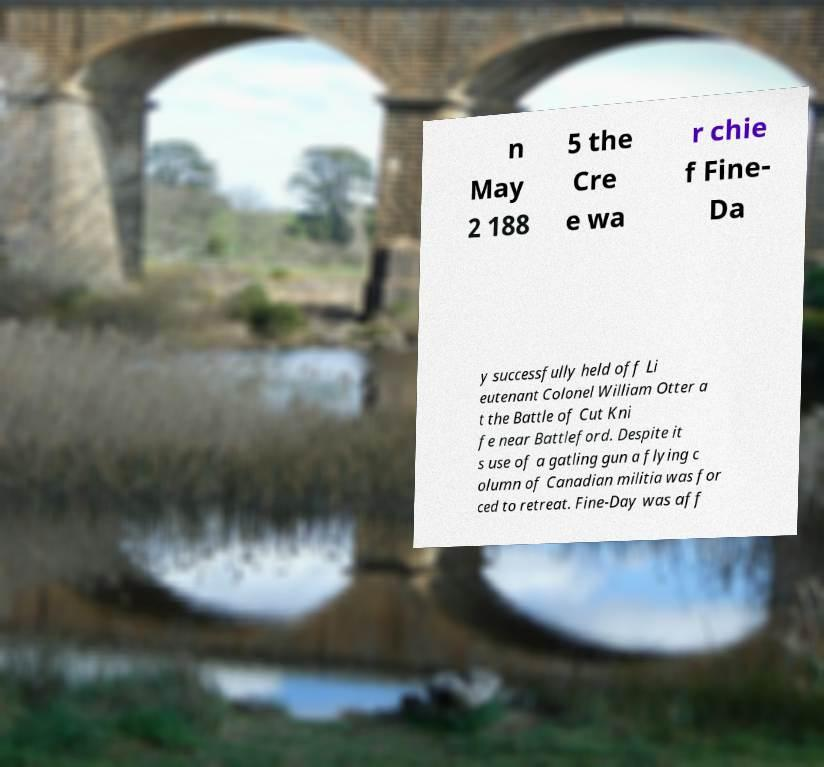Could you assist in decoding the text presented in this image and type it out clearly? n May 2 188 5 the Cre e wa r chie f Fine- Da y successfully held off Li eutenant Colonel William Otter a t the Battle of Cut Kni fe near Battleford. Despite it s use of a gatling gun a flying c olumn of Canadian militia was for ced to retreat. Fine-Day was aff 